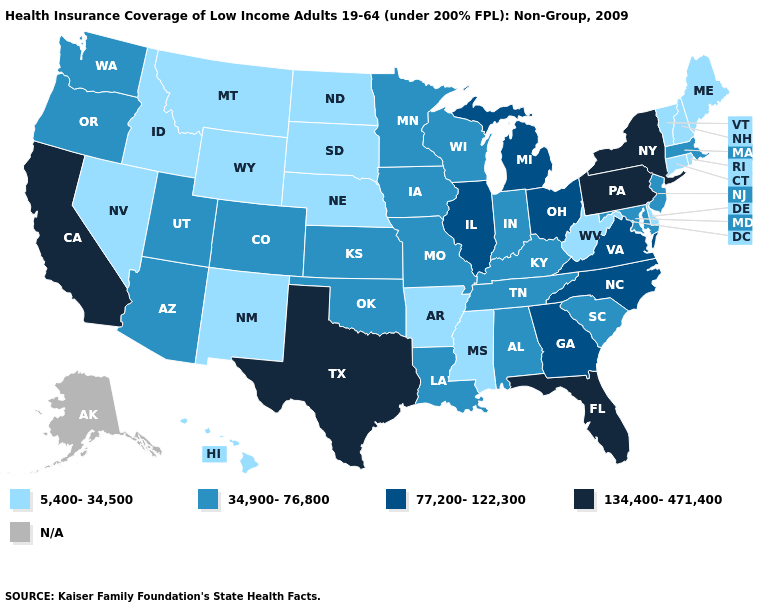Does Idaho have the lowest value in the West?
Concise answer only. Yes. Name the states that have a value in the range 77,200-122,300?
Keep it brief. Georgia, Illinois, Michigan, North Carolina, Ohio, Virginia. Does the first symbol in the legend represent the smallest category?
Be succinct. Yes. Name the states that have a value in the range N/A?
Answer briefly. Alaska. Name the states that have a value in the range 34,900-76,800?
Quick response, please. Alabama, Arizona, Colorado, Indiana, Iowa, Kansas, Kentucky, Louisiana, Maryland, Massachusetts, Minnesota, Missouri, New Jersey, Oklahoma, Oregon, South Carolina, Tennessee, Utah, Washington, Wisconsin. Among the states that border Tennessee , which have the highest value?
Write a very short answer. Georgia, North Carolina, Virginia. What is the value of Georgia?
Answer briefly. 77,200-122,300. Does the first symbol in the legend represent the smallest category?
Keep it brief. Yes. What is the value of Arkansas?
Short answer required. 5,400-34,500. Name the states that have a value in the range N/A?
Be succinct. Alaska. What is the lowest value in the USA?
Short answer required. 5,400-34,500. Name the states that have a value in the range N/A?
Short answer required. Alaska. 